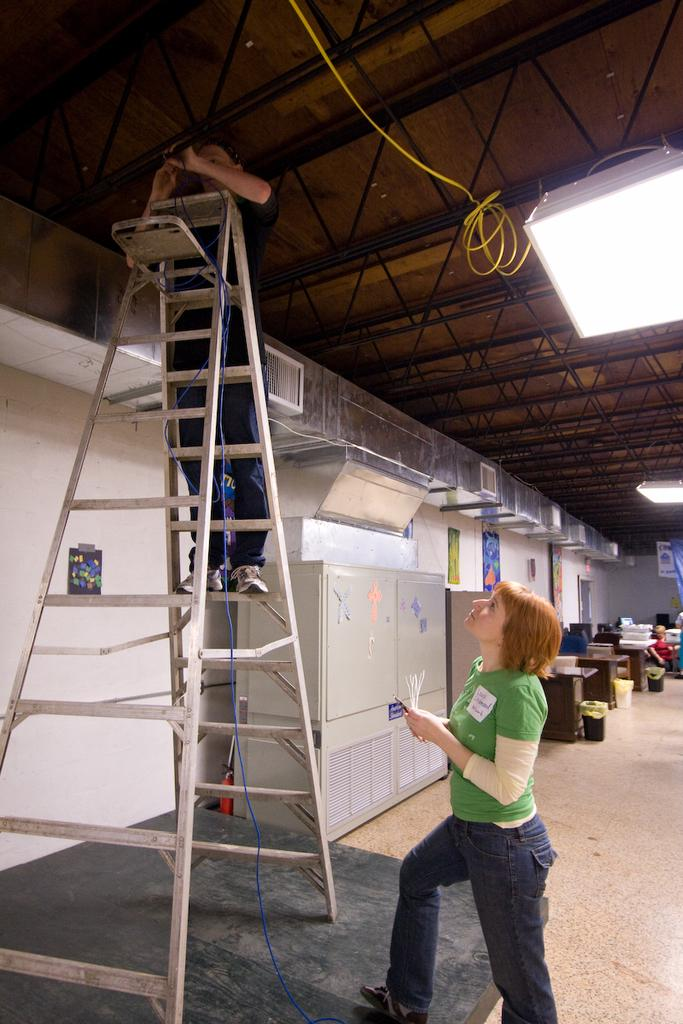What is the person in the image doing? The person is standing on a ladder in the image. Who is present in the image besides the person on the ladder? There is a woman standing below the ladder and watching in the image. What can be seen in the background of the image? There are objects visible in the background of the image. What is the weight of the good-bye that the person on the ladder is expressing in the image? There is no indication of any good-bye or weight in the image; it simply shows a person standing on a ladder with a woman watching below. 